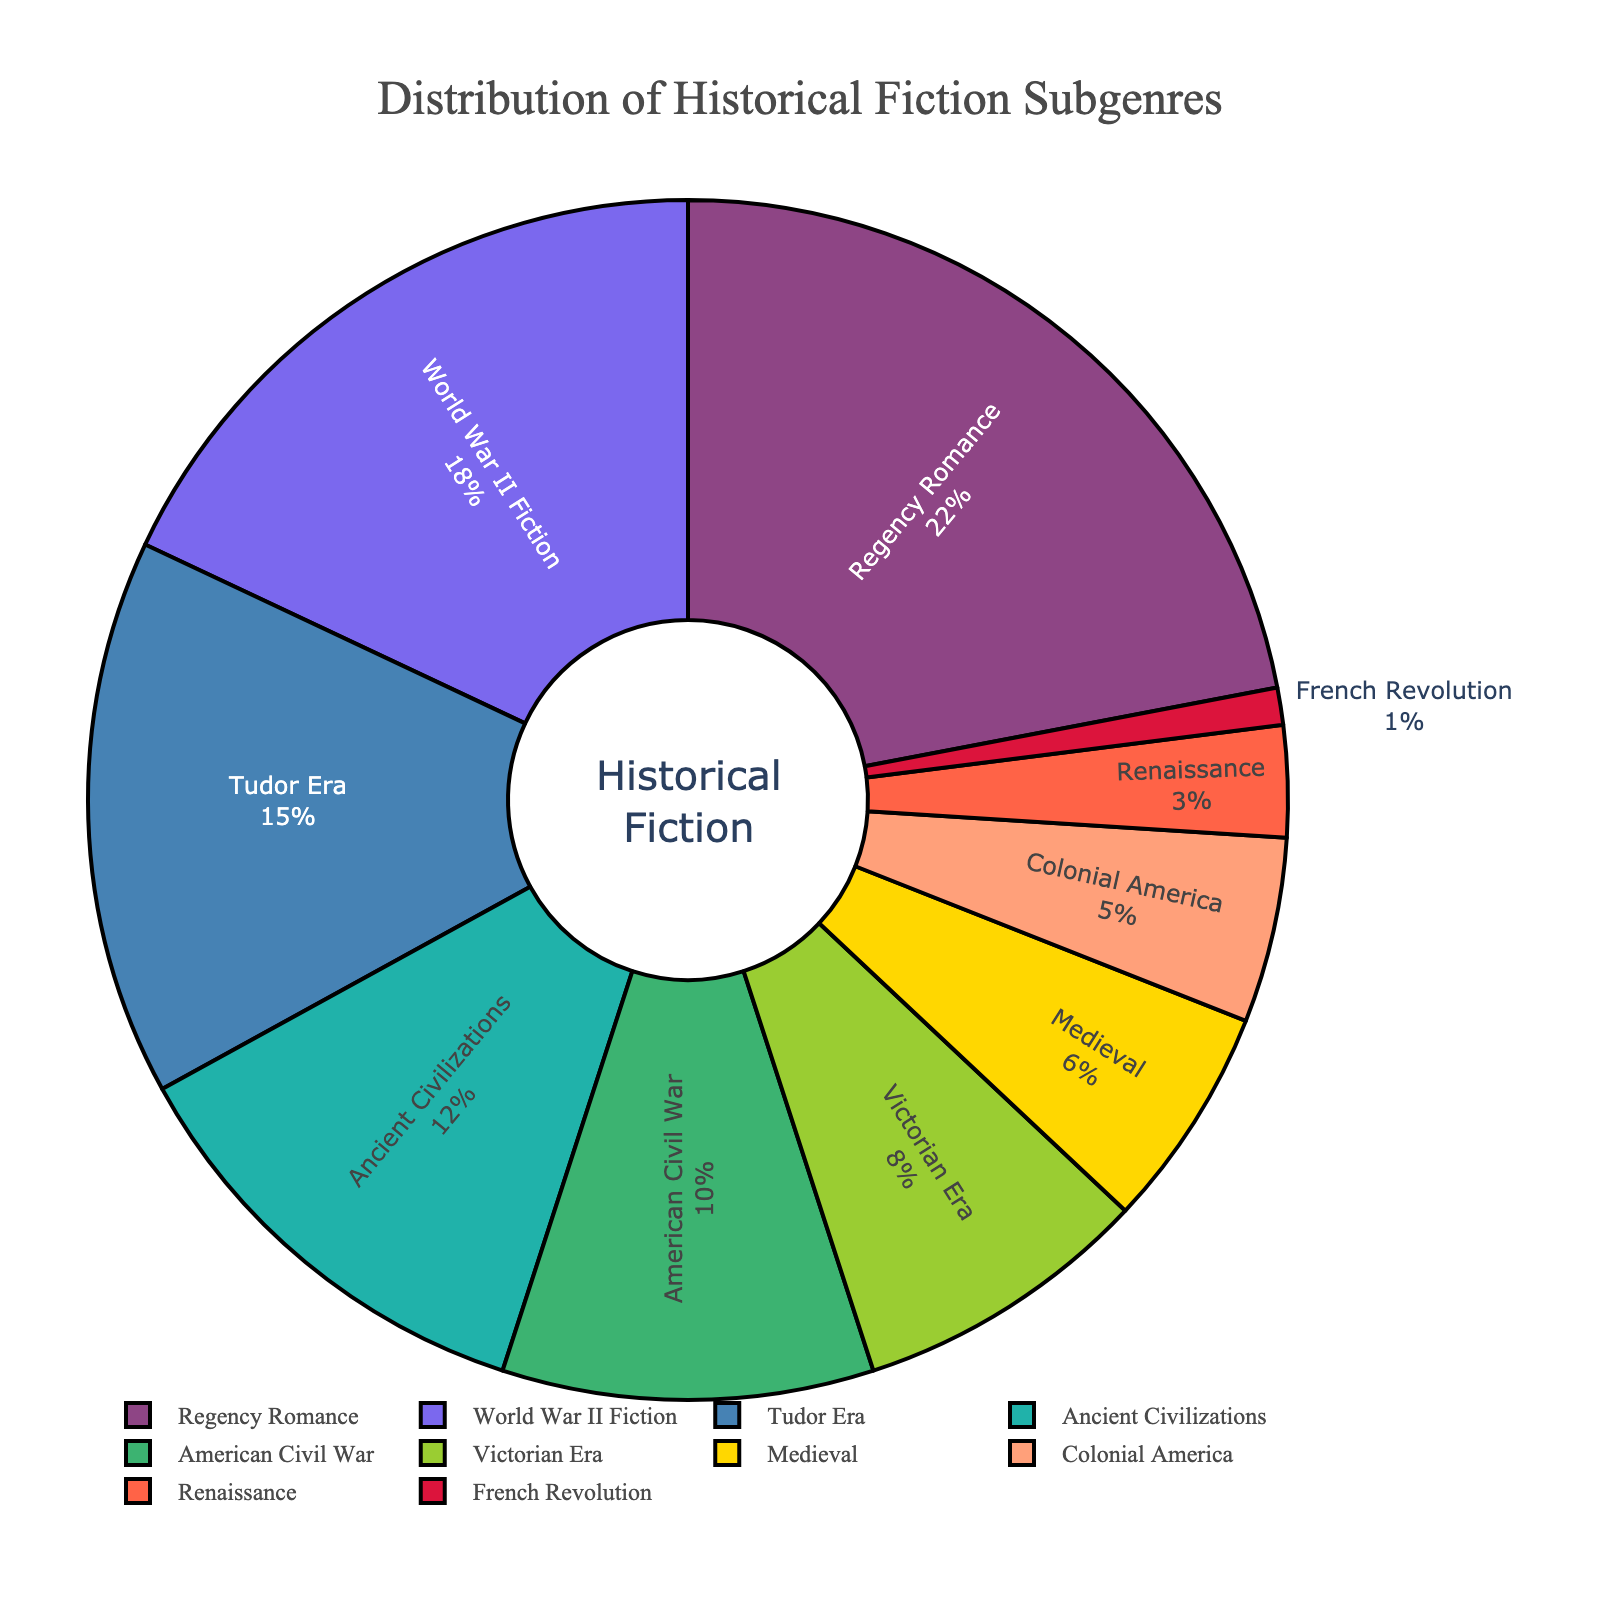Which historical fiction subgenre appears most frequently in the bestseller lists? The most frequent subgenre is the one with the highest percentage on the pie chart. Regency Romance has the largest section, marked at 22%. Therefore, Regency Romance is the most frequent subgenre.
Answer: Regency Romance Which two subgenres combined make up the smallest percentage of the bestseller lists? To find the two subgenres that combined make up the smallest percentage, identify the two subgenres with the smallest individual percentages. The French Revolution subgenre has 1%, and the Renaissance subgenre has 3%. Their combined percentage is 1% + 3% = 4%.
Answer: French Revolution and Renaissance Are there more bestseller subgenres set in the American Civil War or the Tudor Era? Compare the percentages of the American Civil War and Tudor Era subgenres on the pie chart. The American Civil War is marked at 10%, while the Tudor Era is marked at 15%. Therefore, there are more bestsellers in the Tudor Era category.
Answer: Tudor Era If we combine the percentages of Regency Romance and World War II Fiction, what is their total contribution to the bestseller lists? Add the percentages of Regency Romance (22%) and World War II Fiction (18%). The total is 22% + 18% = 40%.
Answer: 40% How does the share of the Victorian Era subgenre compare to that of the Ancient Civilizations? Compare the percentages of the Victorian Era (8%) and Ancient Civilizations (12%) subgenres on the pie chart. The Victorian Era has a smaller percentage than Ancient Civilizations.
Answer: Less Which subgenre is represented by a green color in the pie chart? By referring to the color coding in the plotting script, the green color corresponds to the American Civil War subgenre.
Answer: American Civil War How many subgenres have a percentage greater than or equal to 10%? Count the subgenres with percentages 10% or higher from the pie chart: Regency Romance (22%), World War II Fiction (18%), Tudor Era (15%), Ancient Civilizations (12%), and American Civil War (10%). There are 5 such subgenres.
Answer: 5 What's the total percentage of subgenres set before the 20th century? Identify and sum the percentages of subgenres set before the 20th century: Regency Romance (22%), Tudor Era (15%), Ancient Civilizations (12%), American Civil War (10%), Victorian Era (8%), Medieval (6%), Colonial America (5%), Renaissance (3%), and French Revolution (1%). The total is 22% + 15% + 12% + 10% + 8% + 6% + 5% + 3% + 1% = 82%.
Answer: 82% 